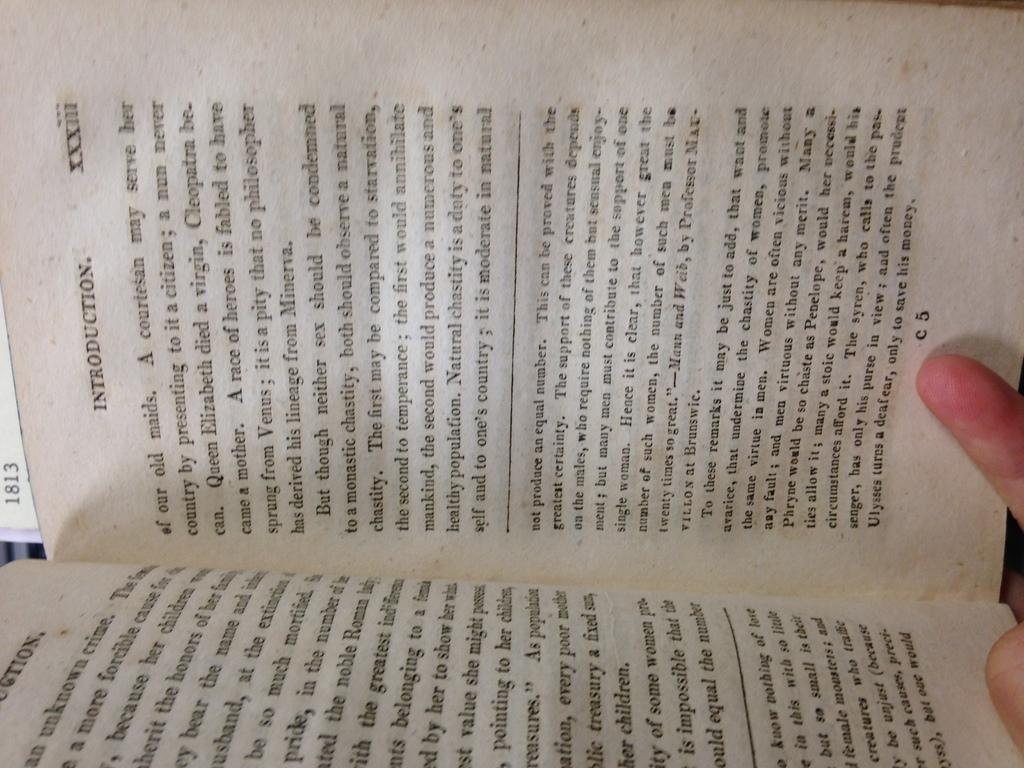Provide a one-sentence caption for the provided image. The introduction page of a typed book shown on page C5. 